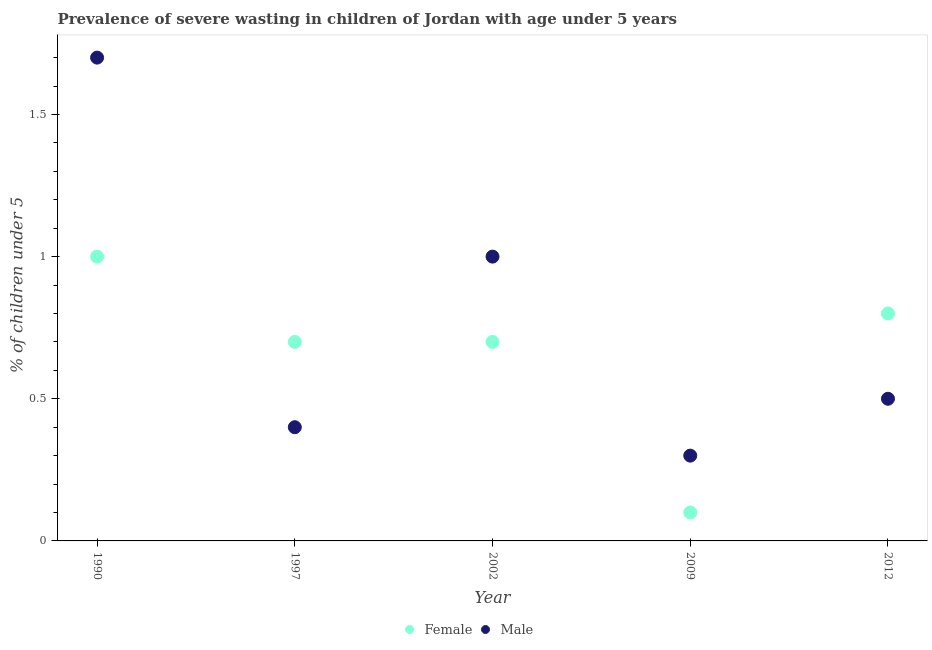Across all years, what is the maximum percentage of undernourished female children?
Keep it short and to the point. 1. Across all years, what is the minimum percentage of undernourished female children?
Ensure brevity in your answer.  0.1. In which year was the percentage of undernourished male children maximum?
Ensure brevity in your answer.  1990. What is the total percentage of undernourished male children in the graph?
Offer a very short reply. 3.9. What is the difference between the percentage of undernourished female children in 1990 and that in 2012?
Keep it short and to the point. 0.2. What is the difference between the percentage of undernourished male children in 1990 and the percentage of undernourished female children in 2009?
Make the answer very short. 1.6. What is the average percentage of undernourished female children per year?
Provide a succinct answer. 0.66. In the year 2002, what is the difference between the percentage of undernourished female children and percentage of undernourished male children?
Your answer should be very brief. -0.3. What is the ratio of the percentage of undernourished female children in 1990 to that in 2012?
Offer a terse response. 1.25. What is the difference between the highest and the second highest percentage of undernourished male children?
Offer a terse response. 0.7. What is the difference between the highest and the lowest percentage of undernourished male children?
Provide a short and direct response. 1.4. In how many years, is the percentage of undernourished male children greater than the average percentage of undernourished male children taken over all years?
Offer a very short reply. 2. Is the percentage of undernourished male children strictly less than the percentage of undernourished female children over the years?
Provide a succinct answer. No. How many dotlines are there?
Your answer should be very brief. 2. How many years are there in the graph?
Your answer should be compact. 5. Does the graph contain any zero values?
Your response must be concise. No. Does the graph contain grids?
Your answer should be very brief. No. Where does the legend appear in the graph?
Provide a short and direct response. Bottom center. What is the title of the graph?
Your response must be concise. Prevalence of severe wasting in children of Jordan with age under 5 years. What is the label or title of the Y-axis?
Give a very brief answer.  % of children under 5. What is the  % of children under 5 of Female in 1990?
Provide a short and direct response. 1. What is the  % of children under 5 in Male in 1990?
Make the answer very short. 1.7. What is the  % of children under 5 of Female in 1997?
Offer a very short reply. 0.7. What is the  % of children under 5 in Male in 1997?
Make the answer very short. 0.4. What is the  % of children under 5 of Female in 2002?
Provide a succinct answer. 0.7. What is the  % of children under 5 in Female in 2009?
Ensure brevity in your answer.  0.1. What is the  % of children under 5 in Male in 2009?
Provide a short and direct response. 0.3. What is the  % of children under 5 in Female in 2012?
Make the answer very short. 0.8. What is the  % of children under 5 in Male in 2012?
Your answer should be compact. 0.5. Across all years, what is the maximum  % of children under 5 in Female?
Give a very brief answer. 1. Across all years, what is the maximum  % of children under 5 in Male?
Your answer should be very brief. 1.7. Across all years, what is the minimum  % of children under 5 of Female?
Your response must be concise. 0.1. Across all years, what is the minimum  % of children under 5 in Male?
Keep it short and to the point. 0.3. What is the total  % of children under 5 in Male in the graph?
Offer a terse response. 3.9. What is the difference between the  % of children under 5 of Female in 1990 and that in 1997?
Your response must be concise. 0.3. What is the difference between the  % of children under 5 in Female in 1990 and that in 2002?
Offer a terse response. 0.3. What is the difference between the  % of children under 5 in Male in 1990 and that in 2002?
Your answer should be very brief. 0.7. What is the difference between the  % of children under 5 of Female in 1990 and that in 2009?
Ensure brevity in your answer.  0.9. What is the difference between the  % of children under 5 of Male in 1990 and that in 2009?
Offer a terse response. 1.4. What is the difference between the  % of children under 5 in Male in 1990 and that in 2012?
Make the answer very short. 1.2. What is the difference between the  % of children under 5 of Female in 1997 and that in 2002?
Ensure brevity in your answer.  0. What is the difference between the  % of children under 5 of Male in 1997 and that in 2002?
Offer a terse response. -0.6. What is the difference between the  % of children under 5 in Female in 1997 and that in 2012?
Your answer should be very brief. -0.1. What is the difference between the  % of children under 5 in Male in 1997 and that in 2012?
Your answer should be compact. -0.1. What is the difference between the  % of children under 5 of Female in 2002 and that in 2009?
Provide a short and direct response. 0.6. What is the difference between the  % of children under 5 of Male in 2002 and that in 2012?
Ensure brevity in your answer.  0.5. What is the difference between the  % of children under 5 of Female in 2009 and that in 2012?
Keep it short and to the point. -0.7. What is the difference between the  % of children under 5 in Female in 1990 and the  % of children under 5 in Male in 2012?
Ensure brevity in your answer.  0.5. What is the difference between the  % of children under 5 in Female in 1997 and the  % of children under 5 in Male in 2002?
Offer a terse response. -0.3. What is the difference between the  % of children under 5 of Female in 1997 and the  % of children under 5 of Male in 2009?
Make the answer very short. 0.4. What is the difference between the  % of children under 5 in Female in 1997 and the  % of children under 5 in Male in 2012?
Offer a terse response. 0.2. What is the average  % of children under 5 in Female per year?
Your answer should be compact. 0.66. What is the average  % of children under 5 of Male per year?
Offer a very short reply. 0.78. In the year 1997, what is the difference between the  % of children under 5 of Female and  % of children under 5 of Male?
Offer a very short reply. 0.3. In the year 2009, what is the difference between the  % of children under 5 of Female and  % of children under 5 of Male?
Ensure brevity in your answer.  -0.2. In the year 2012, what is the difference between the  % of children under 5 of Female and  % of children under 5 of Male?
Make the answer very short. 0.3. What is the ratio of the  % of children under 5 in Female in 1990 to that in 1997?
Offer a very short reply. 1.43. What is the ratio of the  % of children under 5 in Male in 1990 to that in 1997?
Give a very brief answer. 4.25. What is the ratio of the  % of children under 5 of Female in 1990 to that in 2002?
Your answer should be compact. 1.43. What is the ratio of the  % of children under 5 of Male in 1990 to that in 2002?
Your answer should be very brief. 1.7. What is the ratio of the  % of children under 5 of Male in 1990 to that in 2009?
Offer a very short reply. 5.67. What is the ratio of the  % of children under 5 in Female in 1990 to that in 2012?
Provide a short and direct response. 1.25. What is the ratio of the  % of children under 5 of Male in 1990 to that in 2012?
Make the answer very short. 3.4. What is the ratio of the  % of children under 5 in Male in 1997 to that in 2002?
Your response must be concise. 0.4. What is the ratio of the  % of children under 5 in Female in 1997 to that in 2009?
Make the answer very short. 7. What is the ratio of the  % of children under 5 in Male in 1997 to that in 2009?
Provide a succinct answer. 1.33. What is the ratio of the  % of children under 5 in Male in 1997 to that in 2012?
Keep it short and to the point. 0.8. What is the ratio of the  % of children under 5 of Female in 2002 to that in 2009?
Your answer should be compact. 7. What is the ratio of the  % of children under 5 of Male in 2002 to that in 2009?
Provide a succinct answer. 3.33. What is the ratio of the  % of children under 5 in Female in 2002 to that in 2012?
Your answer should be compact. 0.88. What is the ratio of the  % of children under 5 in Male in 2002 to that in 2012?
Your answer should be very brief. 2. What is the ratio of the  % of children under 5 in Male in 2009 to that in 2012?
Keep it short and to the point. 0.6. What is the difference between the highest and the second highest  % of children under 5 in Female?
Give a very brief answer. 0.2. What is the difference between the highest and the lowest  % of children under 5 in Male?
Provide a succinct answer. 1.4. 